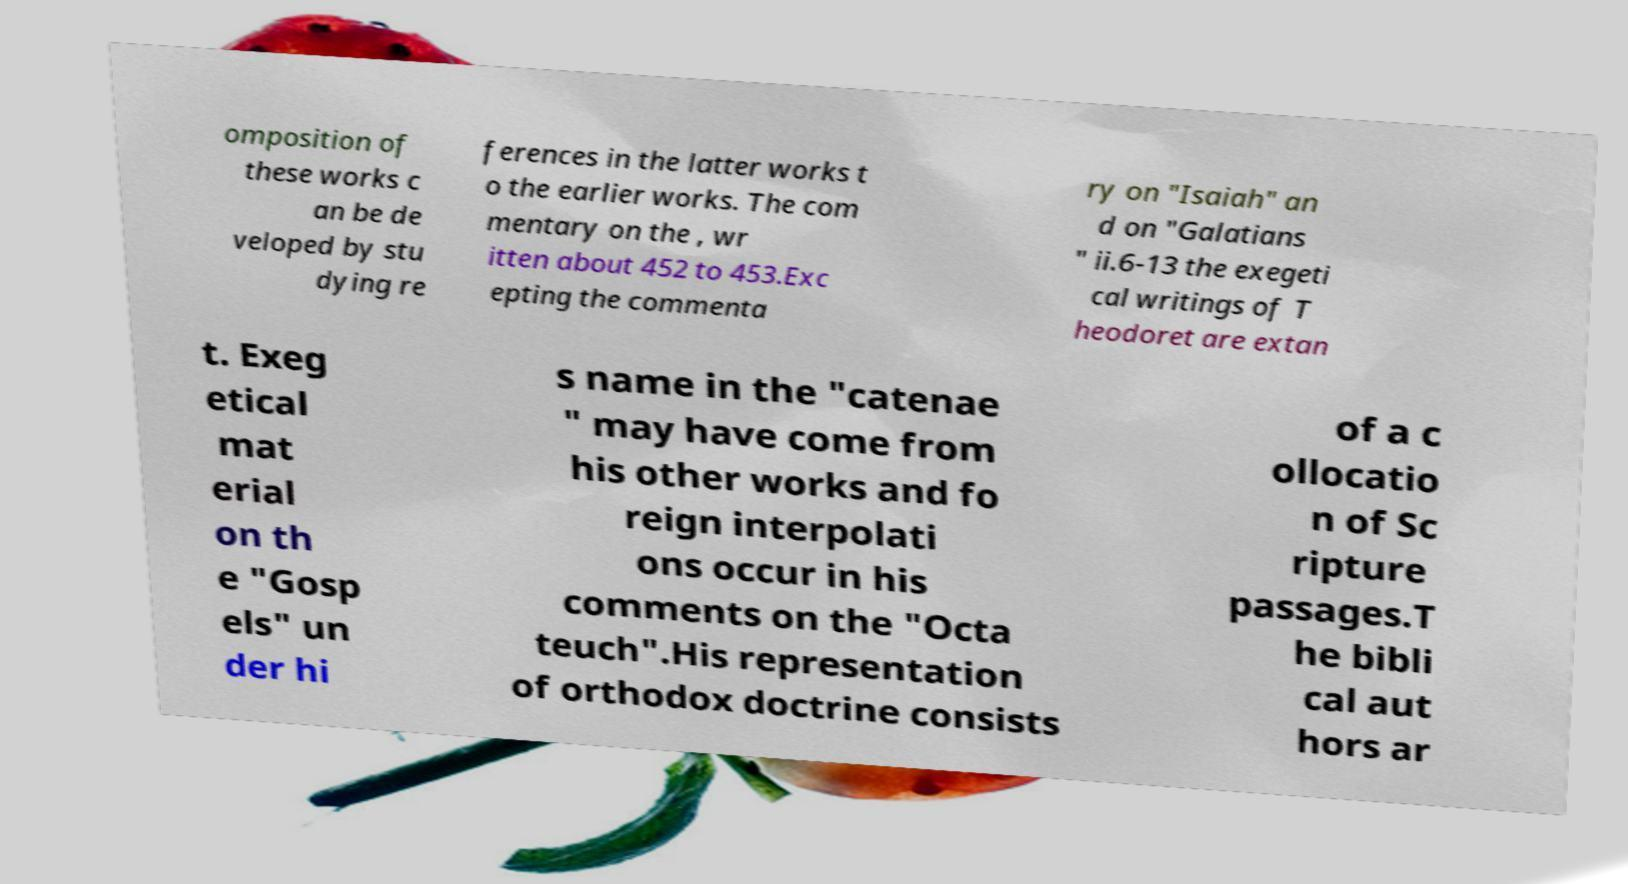There's text embedded in this image that I need extracted. Can you transcribe it verbatim? omposition of these works c an be de veloped by stu dying re ferences in the latter works t o the earlier works. The com mentary on the , wr itten about 452 to 453.Exc epting the commenta ry on "Isaiah" an d on "Galatians " ii.6-13 the exegeti cal writings of T heodoret are extan t. Exeg etical mat erial on th e "Gosp els" un der hi s name in the "catenae " may have come from his other works and fo reign interpolati ons occur in his comments on the "Octa teuch".His representation of orthodox doctrine consists of a c ollocatio n of Sc ripture passages.T he bibli cal aut hors ar 